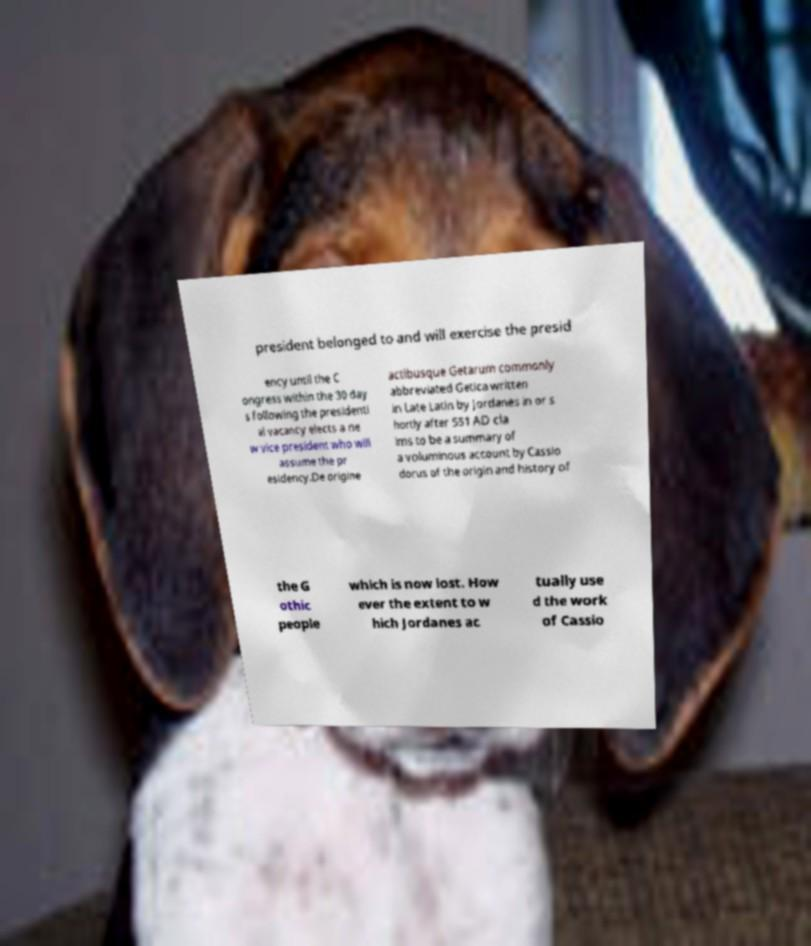For documentation purposes, I need the text within this image transcribed. Could you provide that? president belonged to and will exercise the presid ency until the C ongress within the 30 day s following the presidenti al vacancy elects a ne w vice president who will assume the pr esidency.De origine actibusque Getarum commonly abbreviated Getica written in Late Latin by Jordanes in or s hortly after 551 AD cla ims to be a summary of a voluminous account by Cassio dorus of the origin and history of the G othic people which is now lost. How ever the extent to w hich Jordanes ac tually use d the work of Cassio 